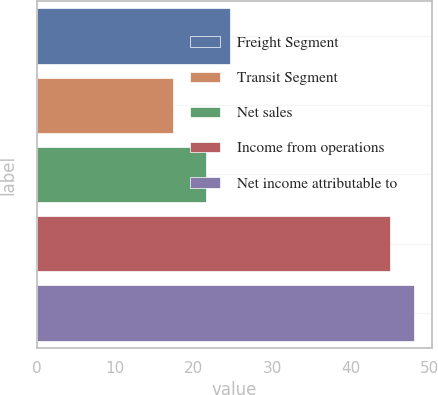<chart> <loc_0><loc_0><loc_500><loc_500><bar_chart><fcel>Freight Segment<fcel>Transit Segment<fcel>Net sales<fcel>Income from operations<fcel>Net income attributable to<nl><fcel>24.55<fcel>17.4<fcel>21.5<fcel>44.9<fcel>47.95<nl></chart> 